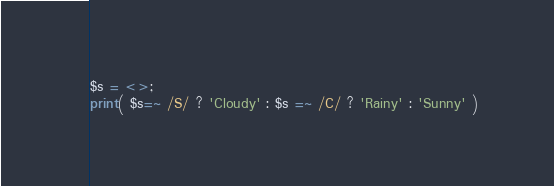<code> <loc_0><loc_0><loc_500><loc_500><_Perl_>$s = <>;
print( $s=~ /S/ ? 'Cloudy' : $s =~ /C/ ? 'Rainy' : 'Sunny' )</code> 